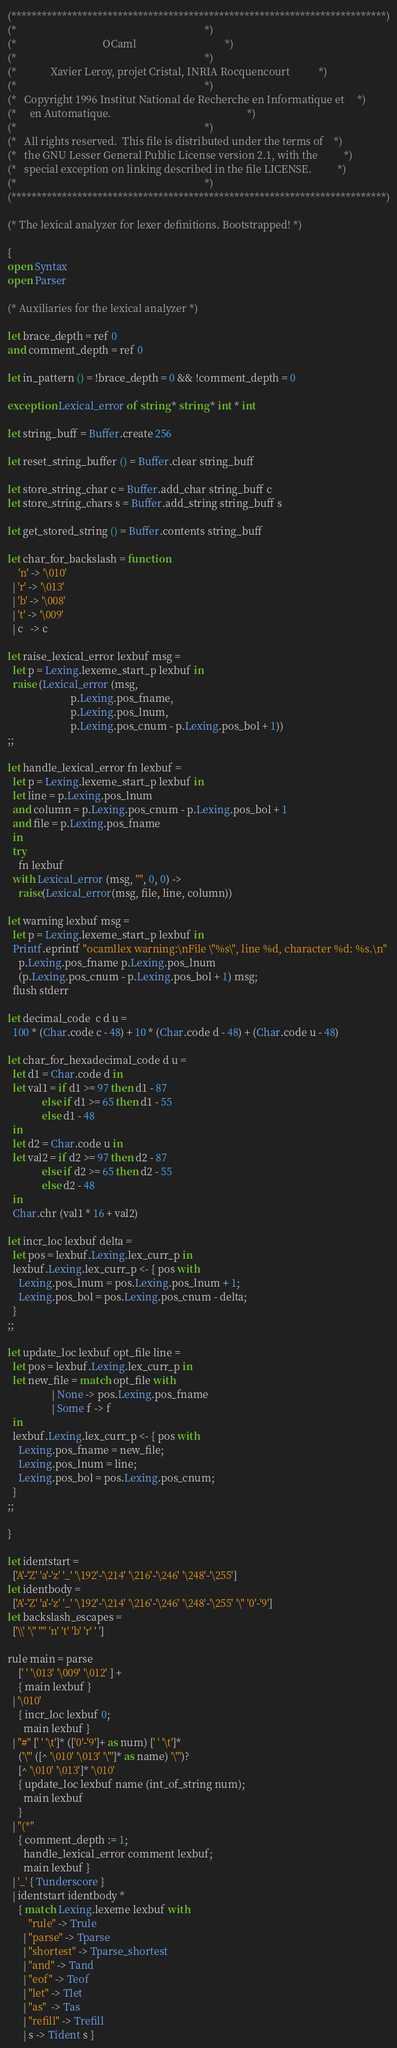<code> <loc_0><loc_0><loc_500><loc_500><_OCaml_>(**************************************************************************)
(*                                                                        *)
(*                                 OCaml                                  *)
(*                                                                        *)
(*             Xavier Leroy, projet Cristal, INRIA Rocquencourt           *)
(*                                                                        *)
(*   Copyright 1996 Institut National de Recherche en Informatique et     *)
(*     en Automatique.                                                    *)
(*                                                                        *)
(*   All rights reserved.  This file is distributed under the terms of    *)
(*   the GNU Lesser General Public License version 2.1, with the          *)
(*   special exception on linking described in the file LICENSE.          *)
(*                                                                        *)
(**************************************************************************)

(* The lexical analyzer for lexer definitions. Bootstrapped! *)

{
open Syntax
open Parser

(* Auxiliaries for the lexical analyzer *)

let brace_depth = ref 0
and comment_depth = ref 0

let in_pattern () = !brace_depth = 0 && !comment_depth = 0

exception Lexical_error of string * string * int * int

let string_buff = Buffer.create 256

let reset_string_buffer () = Buffer.clear string_buff

let store_string_char c = Buffer.add_char string_buff c
let store_string_chars s = Buffer.add_string string_buff s

let get_stored_string () = Buffer.contents string_buff

let char_for_backslash = function
    'n' -> '\010'
  | 'r' -> '\013'
  | 'b' -> '\008'
  | 't' -> '\009'
  | c   -> c

let raise_lexical_error lexbuf msg =
  let p = Lexing.lexeme_start_p lexbuf in
  raise (Lexical_error (msg,
                        p.Lexing.pos_fname,
                        p.Lexing.pos_lnum,
                        p.Lexing.pos_cnum - p.Lexing.pos_bol + 1))
;;

let handle_lexical_error fn lexbuf =
  let p = Lexing.lexeme_start_p lexbuf in
  let line = p.Lexing.pos_lnum
  and column = p.Lexing.pos_cnum - p.Lexing.pos_bol + 1
  and file = p.Lexing.pos_fname
  in
  try
    fn lexbuf
  with Lexical_error (msg, "", 0, 0) ->
    raise(Lexical_error(msg, file, line, column))

let warning lexbuf msg =
  let p = Lexing.lexeme_start_p lexbuf in
  Printf.eprintf "ocamllex warning:\nFile \"%s\", line %d, character %d: %s.\n"
    p.Lexing.pos_fname p.Lexing.pos_lnum
    (p.Lexing.pos_cnum - p.Lexing.pos_bol + 1) msg;
  flush stderr

let decimal_code  c d u =
  100 * (Char.code c - 48) + 10 * (Char.code d - 48) + (Char.code u - 48)

let char_for_hexadecimal_code d u =
  let d1 = Char.code d in
  let val1 = if d1 >= 97 then d1 - 87
             else if d1 >= 65 then d1 - 55
             else d1 - 48
  in
  let d2 = Char.code u in
  let val2 = if d2 >= 97 then d2 - 87
             else if d2 >= 65 then d2 - 55
             else d2 - 48
  in
  Char.chr (val1 * 16 + val2)

let incr_loc lexbuf delta =
  let pos = lexbuf.Lexing.lex_curr_p in
  lexbuf.Lexing.lex_curr_p <- { pos with
    Lexing.pos_lnum = pos.Lexing.pos_lnum + 1;
    Lexing.pos_bol = pos.Lexing.pos_cnum - delta;
  }
;;

let update_loc lexbuf opt_file line =
  let pos = lexbuf.Lexing.lex_curr_p in
  let new_file = match opt_file with
                 | None -> pos.Lexing.pos_fname
                 | Some f -> f
  in
  lexbuf.Lexing.lex_curr_p <- { pos with
    Lexing.pos_fname = new_file;
    Lexing.pos_lnum = line;
    Lexing.pos_bol = pos.Lexing.pos_cnum;
  }
;;

}

let identstart =
  ['A'-'Z' 'a'-'z' '_' '\192'-'\214' '\216'-'\246' '\248'-'\255']
let identbody =
  ['A'-'Z' 'a'-'z' '_' '\192'-'\214' '\216'-'\246' '\248'-'\255' '\'' '0'-'9']
let backslash_escapes =
  ['\\' '\'' '"' 'n' 't' 'b' 'r' ' ']

rule main = parse
    [' ' '\013' '\009' '\012' ] +
    { main lexbuf }
  | '\010'
    { incr_loc lexbuf 0;
      main lexbuf }
  | "#" [' ' '\t']* (['0'-'9']+ as num) [' ' '\t']*
    ('\"' ([^ '\010' '\013' '\"']* as name) '\"')?
    [^ '\010' '\013']* '\010'
    { update_loc lexbuf name (int_of_string num);
      main lexbuf
    }
  | "(*"
    { comment_depth := 1;
      handle_lexical_error comment lexbuf;
      main lexbuf }
  | '_' { Tunderscore }
  | identstart identbody *
    { match Lexing.lexeme lexbuf with
        "rule" -> Trule
      | "parse" -> Tparse
      | "shortest" -> Tparse_shortest
      | "and" -> Tand
      | "eof" -> Teof
      | "let" -> Tlet
      | "as"  -> Tas
      | "refill" -> Trefill
      | s -> Tident s }</code> 